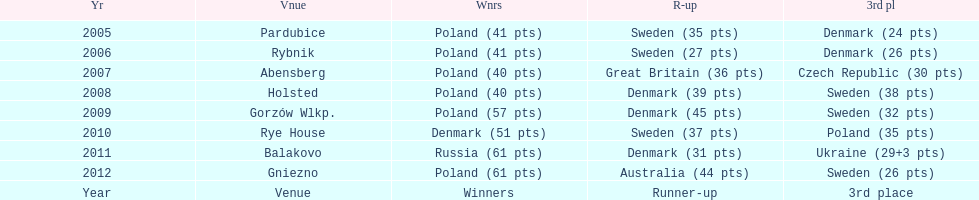Between 2005 and 2012, which team secured the highest number of third-place finishes in the speedway junior world championship? Sweden. 